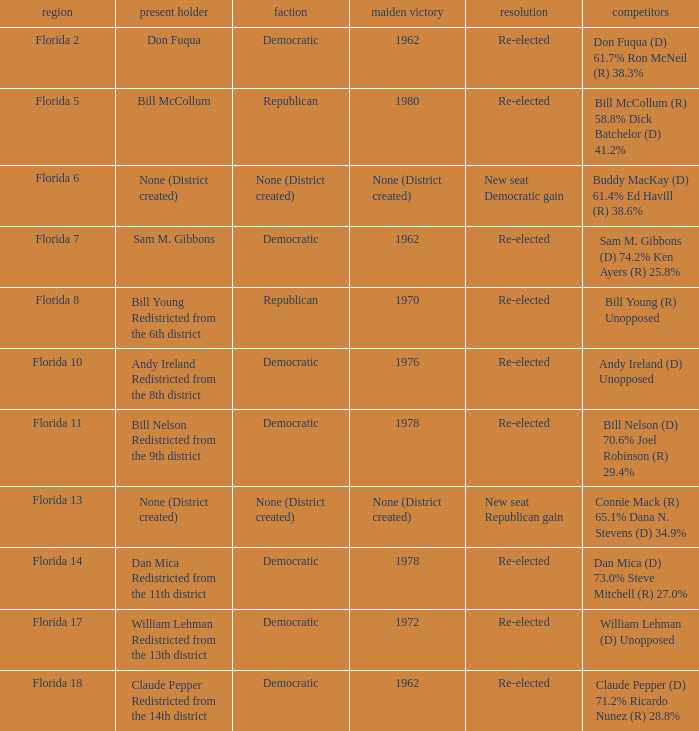Who is the the candidates with incumbent being don fuqua Don Fuqua (D) 61.7% Ron McNeil (R) 38.3%. 